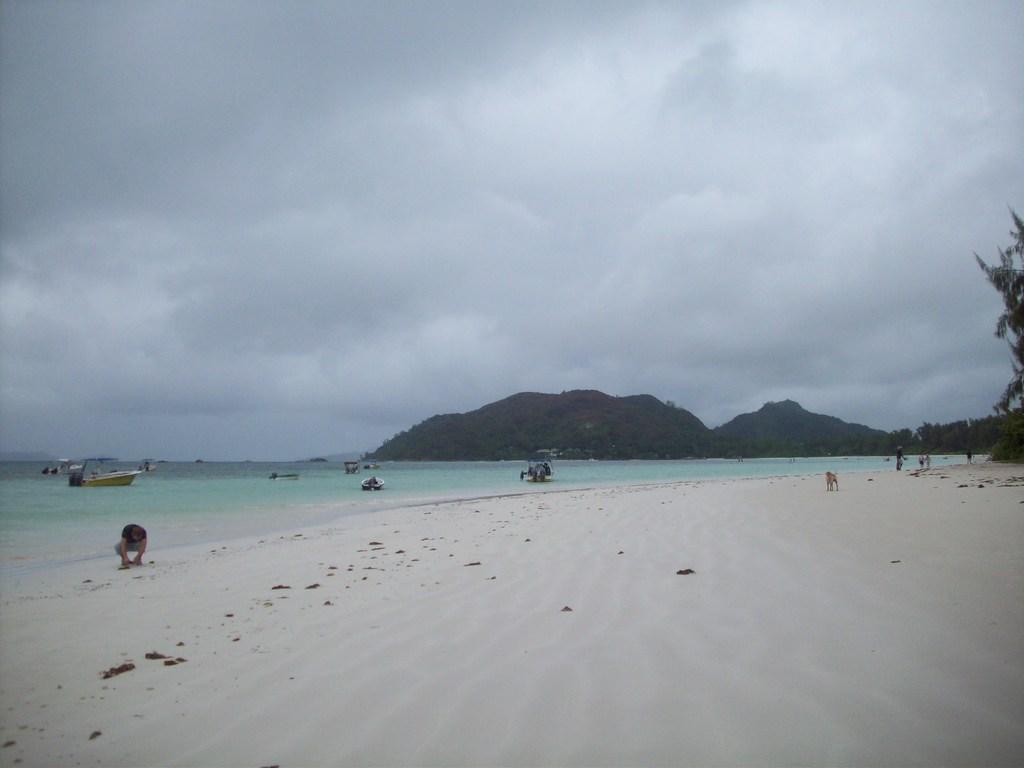In one or two sentences, can you explain what this image depicts? In this picture we can see water on the left side, there are some boats in the water, we can see a person here, on the right side there is a dog, we can see a hill in the background, on the right side there is a tree, we can see the sky at the top of the picture. 